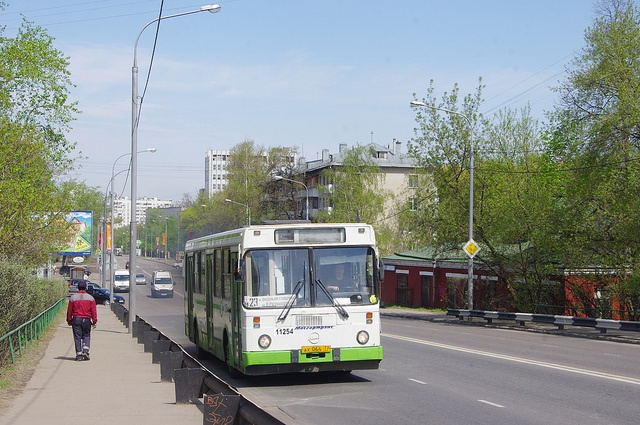Describe the objects in this image and their specific colors. I can see bus in lightblue, white, gray, black, and darkgray tones, people in lightblue, black, gray, darkgray, and brown tones, truck in lightblue, gray, lightgray, darkgray, and darkblue tones, people in lightblue, gray, and darkgray tones, and car in lightblue, black, gray, navy, and darkgray tones in this image. 